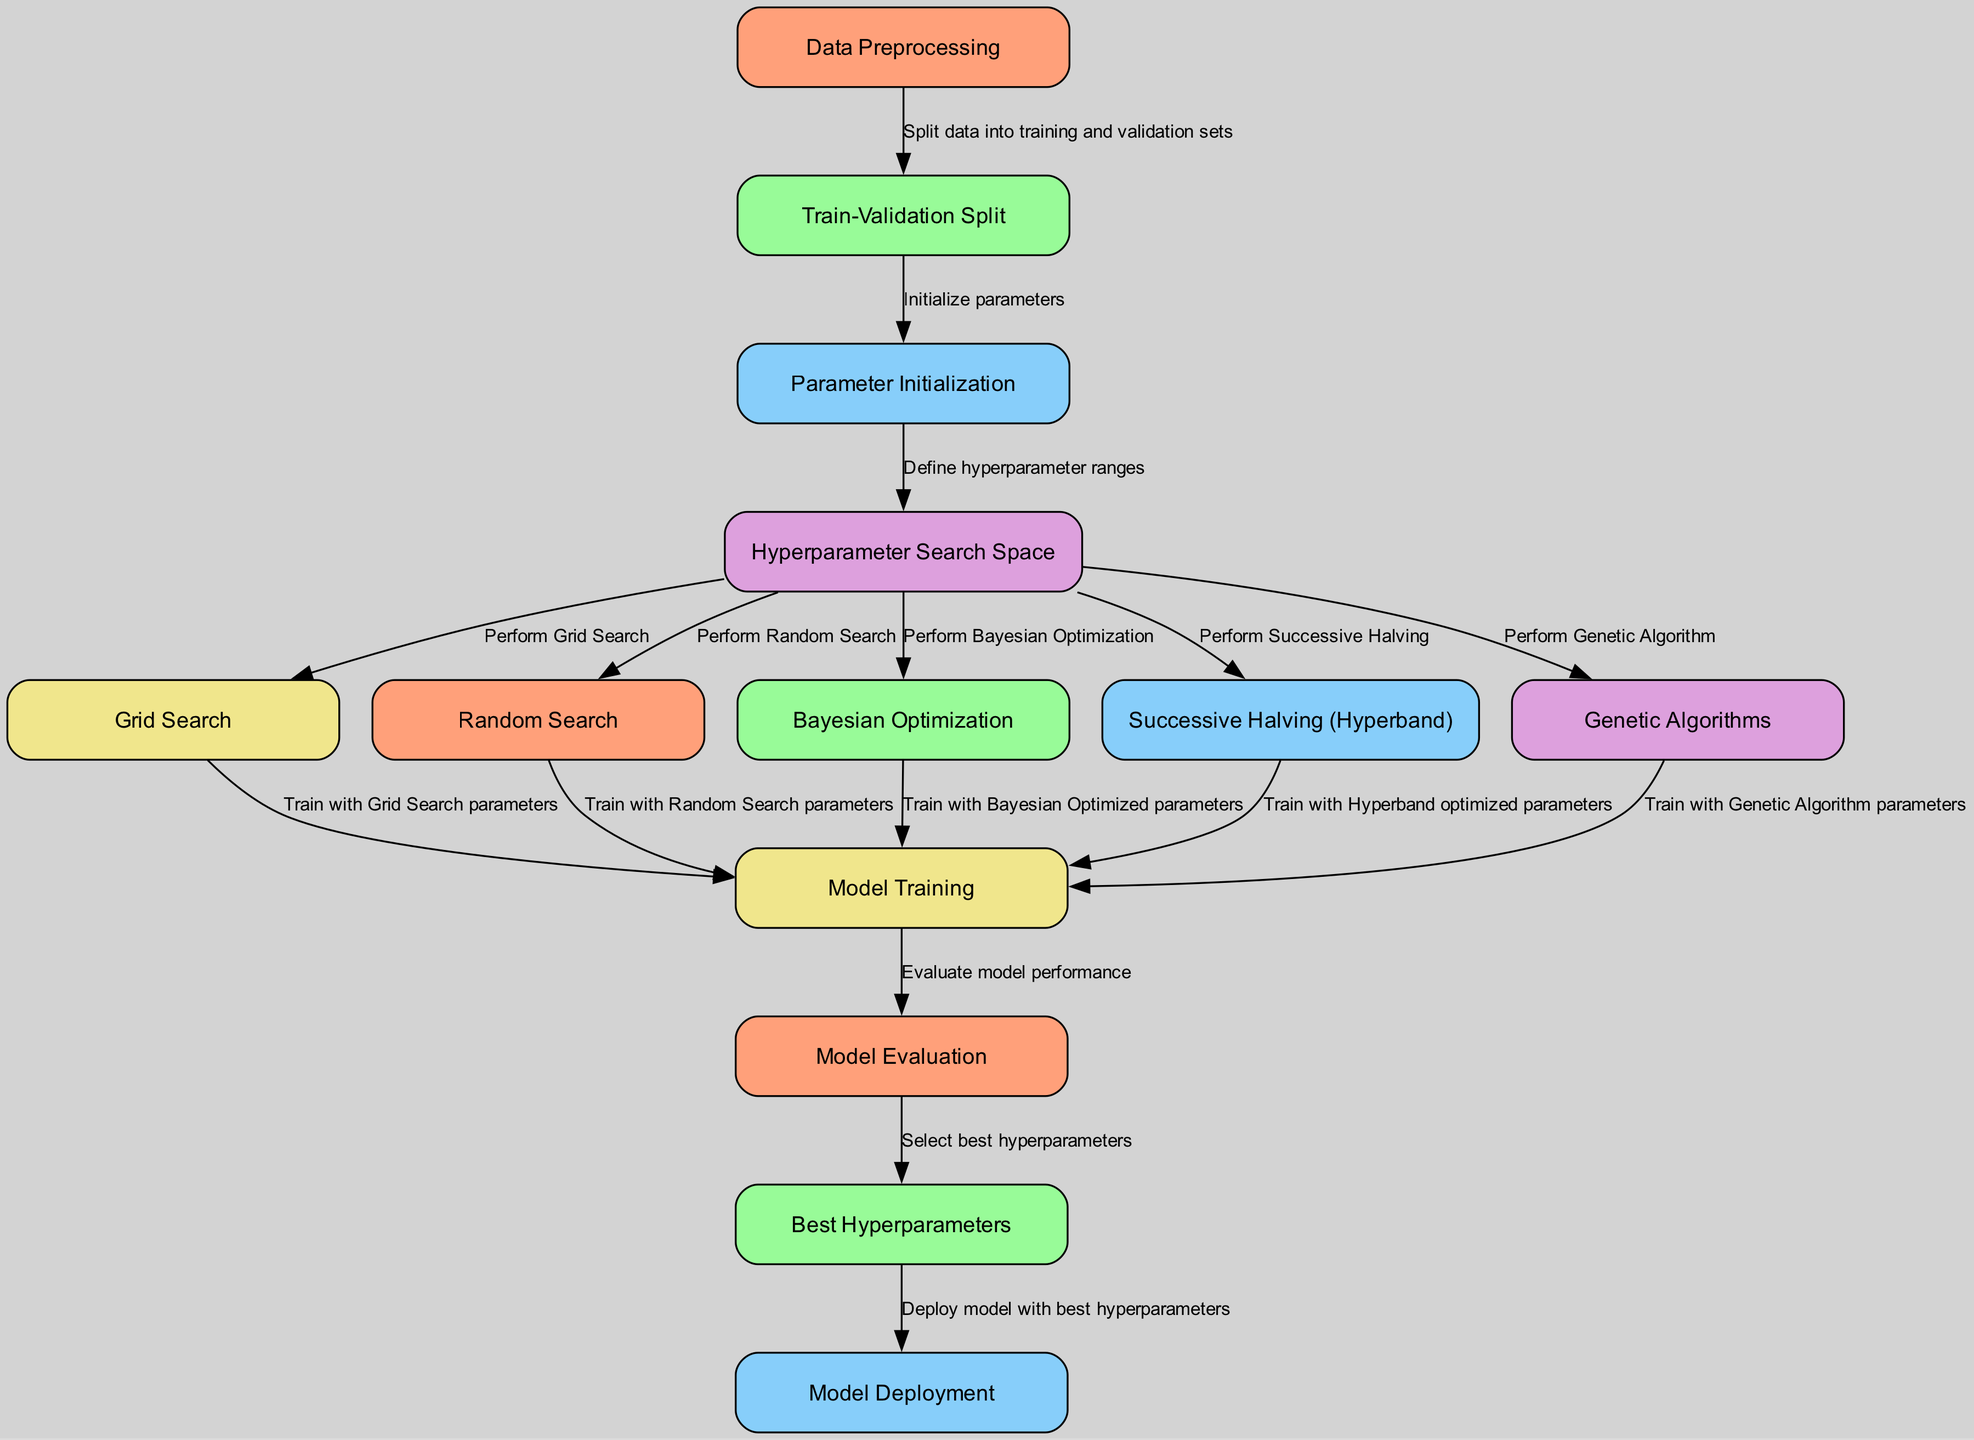What is the starting point of the diagram? The starting point of the diagram is "Data Preprocessing". This is the first node listed in the data, indicating that it is where the process begins.
Answer: Data Preprocessing How many hyperparameter optimization methods are shown in the diagram? The diagram includes five hyperparameter optimization methods: Grid Search, Random Search, Bayesian Optimization, Successive Halving (Hyperband), and Genetic Algorithms. Counting these methods gives a total of five.
Answer: Five What follows after "Model Evaluation"? After "Model Evaluation", the next step in the diagram is "Select best hyperparameters", indicating the action taken with the evaluation results.
Answer: Select best hyperparameters Which nodes are connected to "Hyperparameter Search Space"? The nodes connected to "Hyperparameter Search Space" are Grid Search, Random Search, Bayesian Optimization, Successive Halving (Hyperband), and Genetic Algorithms. This shows that various optimization techniques stem from defining the search space.
Answer: Grid Search, Random Search, Bayesian Optimization, Successive Halving (Hyperband), Genetic Algorithms What is the final step in the diagram? The final step in the diagram is "Deploy model with best hyperparameters", indicating that after selecting the best parameters, the model is prepared for deployment.
Answer: Deploy model with best hyperparameters What is the relationship between "Train-Validation Split" and "Parameter Initialization"? The relationship is that "Train-Validation Split" precedes "Parameter Initialization". This indicates that the data must first be split into training and validation sets before any parameters can be initialized for model training.
Answer: "Train-Validation Split" precedes "Parameter Initialization" Which two optimization methods involve randomness in their process? The two optimization methods that involve randomness are "Random Search" and "Genetic Algorithms". Both techniques incorporate stochastic processes in their search for optimal hyperparameters.
Answer: Random Search, Genetic Algorithms How many steps are there from "Model Training" to "Model Deployment"? There are two steps from "Model Training" to "Model Deployment". After training the model, it undergoes evaluation, followed by the selection of the best hyperparameters before deployment.
Answer: Two steps 